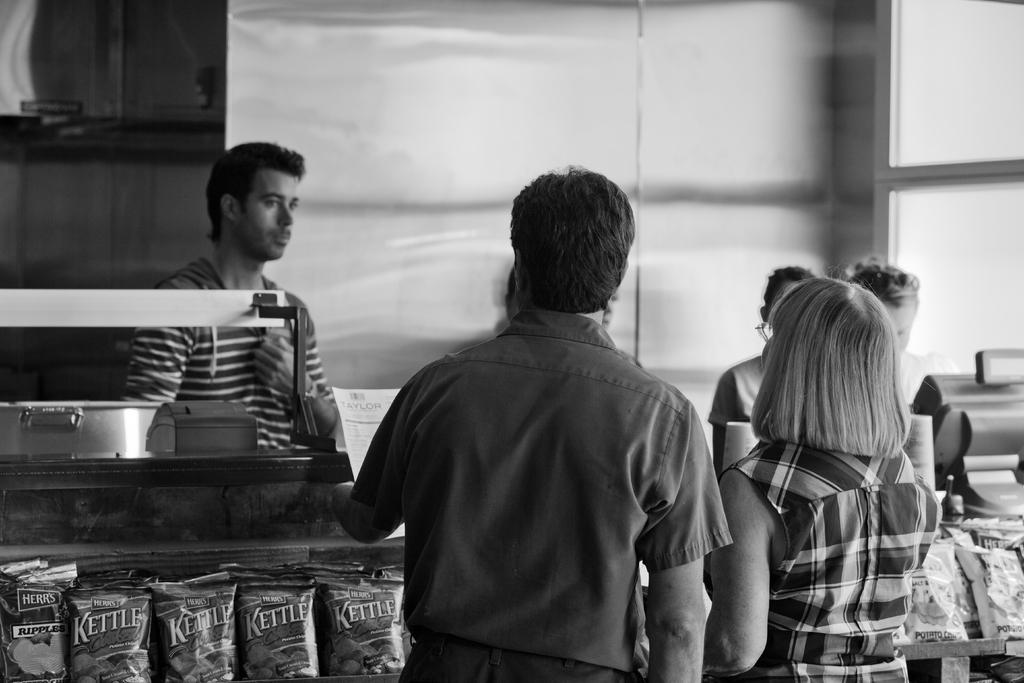What is happening in the image? There are people standing near a desk in the image. What can be seen on the desk? There are edible packs visible on the desk. How are the edible packsble packs protected or displayed? The edible packs are behind a glass surface. How many people are standing near the desk? At least one person is standing near the desk. What is the distance between the desk and the organization in the image? There is no organization mentioned or visible in the image, and therefore no distance can be determined. Is there any poison present in the edible packs on the desk? The image does not provide any information about the contents of the edible packs, so it cannot be determined if there is poison present. 